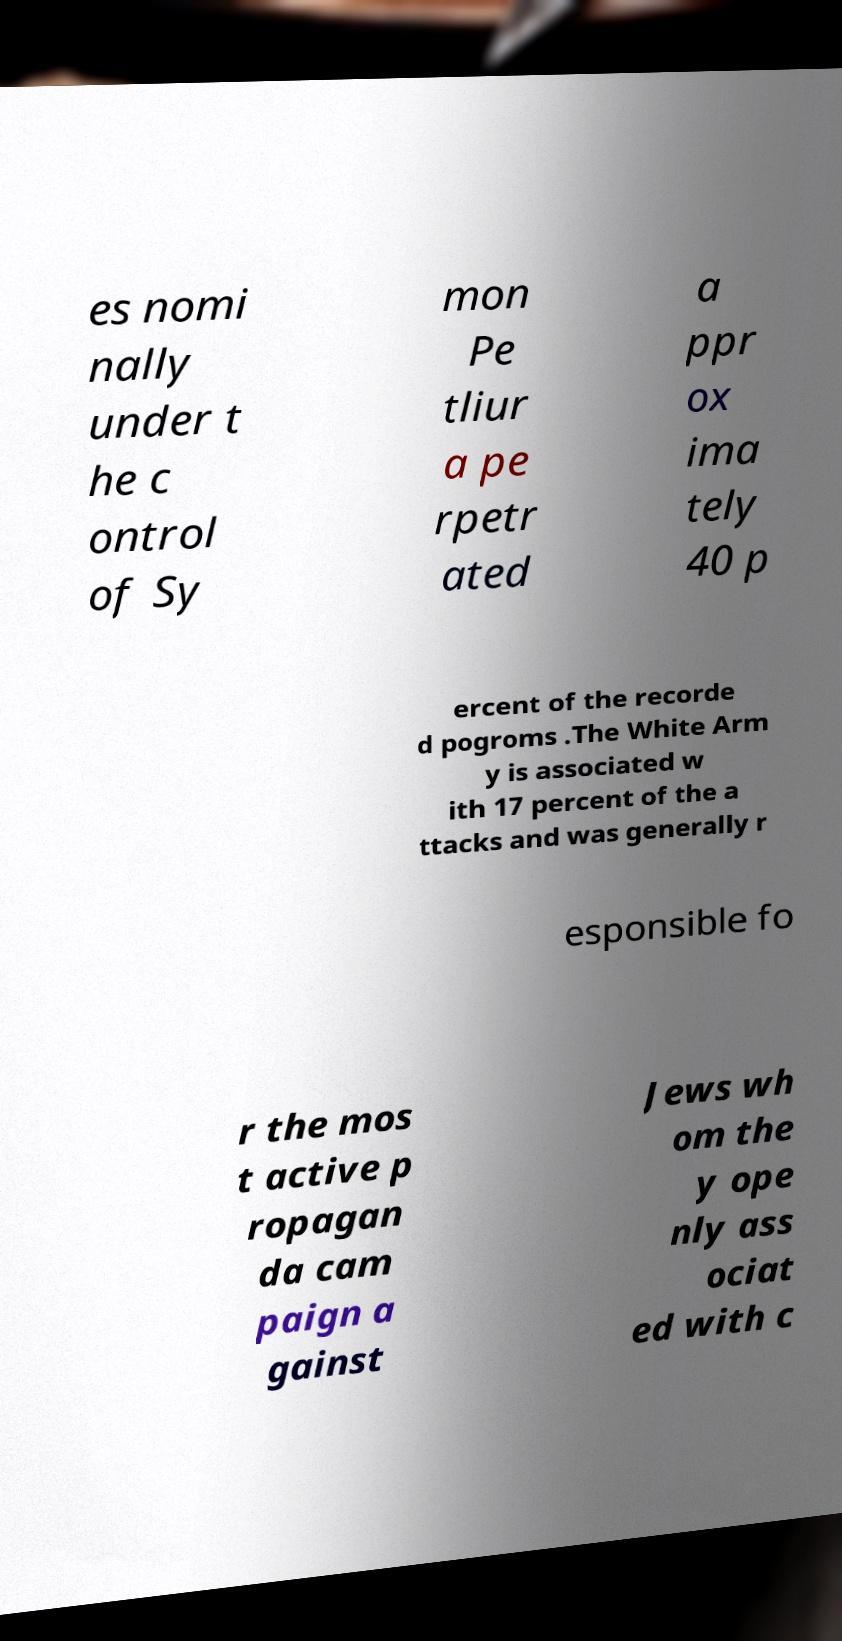Please identify and transcribe the text found in this image. es nomi nally under t he c ontrol of Sy mon Pe tliur a pe rpetr ated a ppr ox ima tely 40 p ercent of the recorde d pogroms .The White Arm y is associated w ith 17 percent of the a ttacks and was generally r esponsible fo r the mos t active p ropagan da cam paign a gainst Jews wh om the y ope nly ass ociat ed with c 